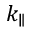<formula> <loc_0><loc_0><loc_500><loc_500>k _ { \| }</formula> 